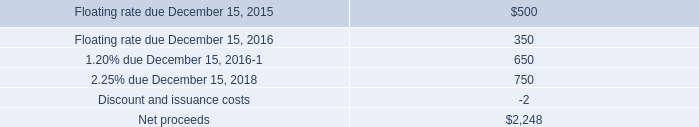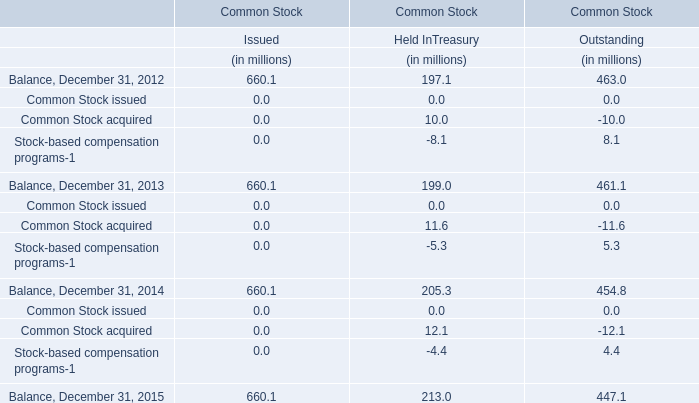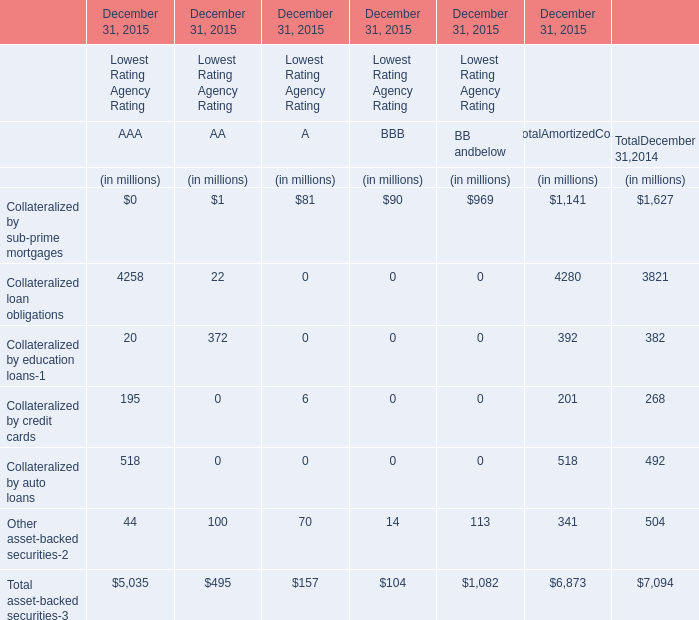What's the growth rate of Collateralized loan obligations for total amortized cost in 2015? (in %) 
Computations: ((4280 - 3821) / 3821)
Answer: 0.12013. 